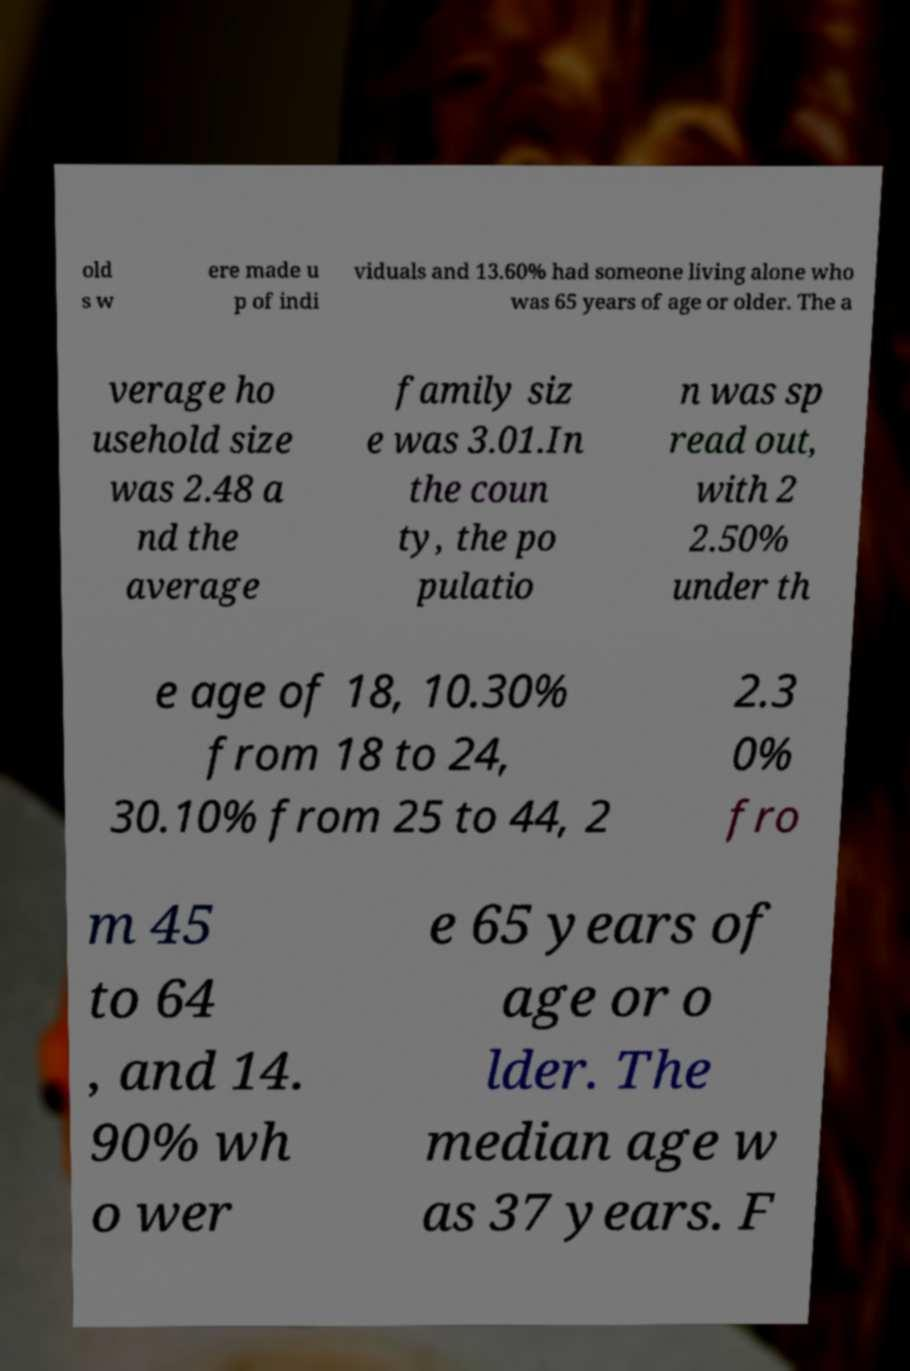Can you read and provide the text displayed in the image?This photo seems to have some interesting text. Can you extract and type it out for me? old s w ere made u p of indi viduals and 13.60% had someone living alone who was 65 years of age or older. The a verage ho usehold size was 2.48 a nd the average family siz e was 3.01.In the coun ty, the po pulatio n was sp read out, with 2 2.50% under th e age of 18, 10.30% from 18 to 24, 30.10% from 25 to 44, 2 2.3 0% fro m 45 to 64 , and 14. 90% wh o wer e 65 years of age or o lder. The median age w as 37 years. F 